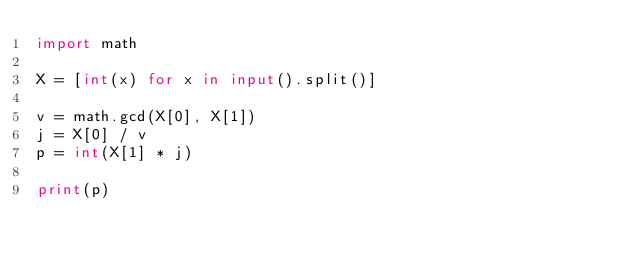Convert code to text. <code><loc_0><loc_0><loc_500><loc_500><_Python_>import math

X = [int(x) for x in input().split()]

v = math.gcd(X[0], X[1])
j = X[0] / v
p = int(X[1] * j)

print(p)</code> 